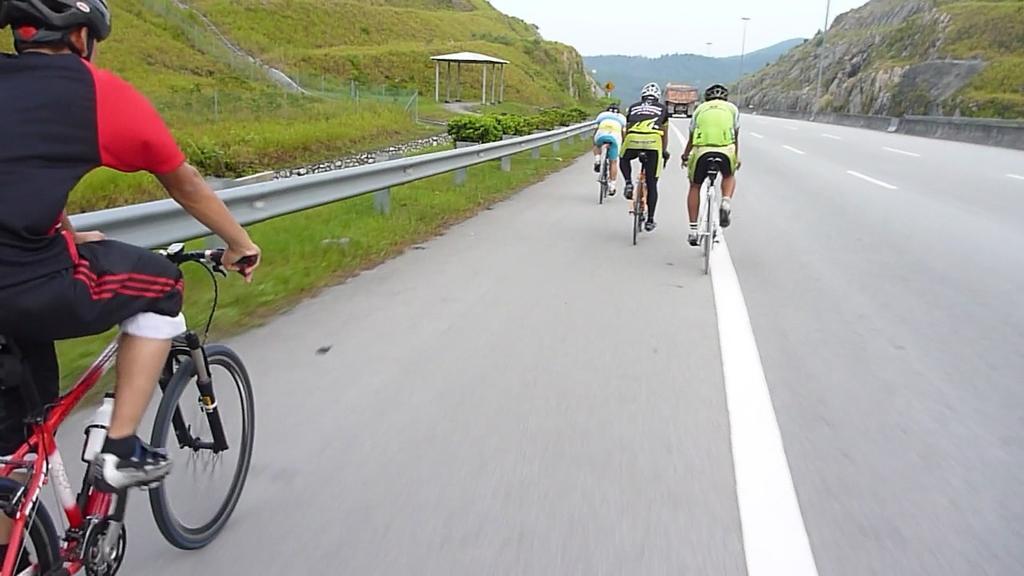How would you summarize this image in a sentence or two? In this picture we can see few people, they are riding bicycles on the road, and they wore helmets, in front of them we can see a truck on the road, beside to them we can see fence, plants and poles. 